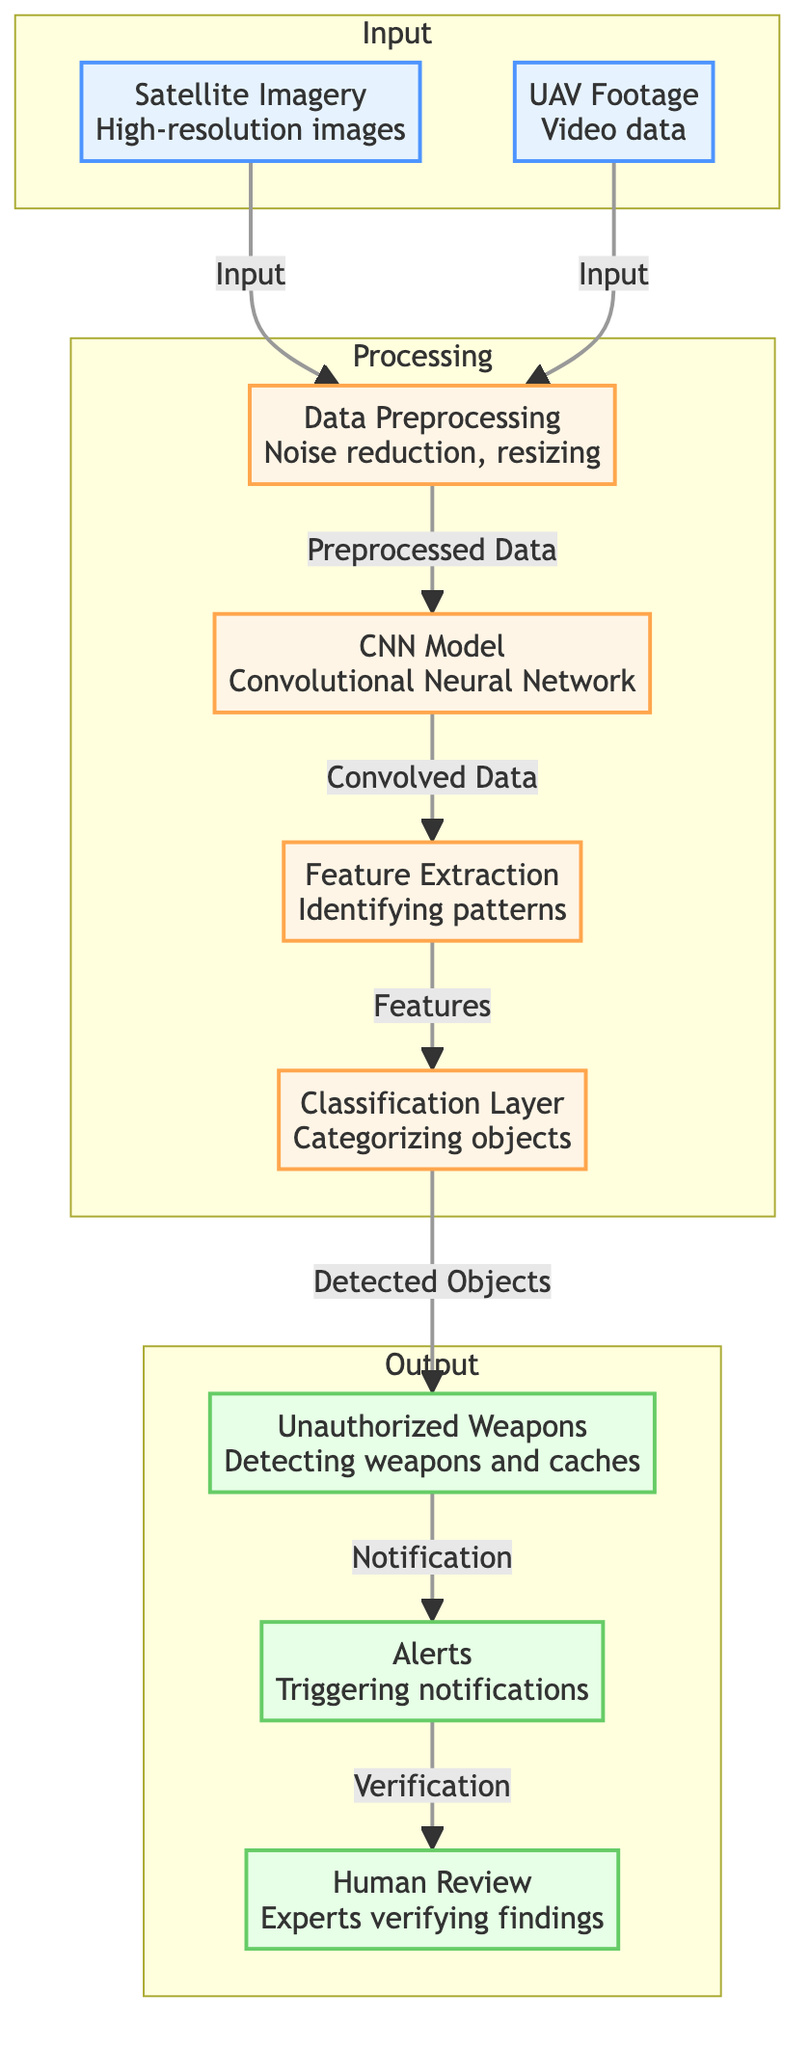What are the two types of input in the diagram? The diagram shows two inputs: one from Satellite Imagery and one from UAV Footage. Both are fed into the Data Preprocessing node as their initial step.
Answer: Satellite Imagery, UAV Footage What is the first processing step after data input? The diagram indicates that after both input types, the first processing step is Data Preprocessing. This step involves noise reduction and resizing of the images and video data.
Answer: Data Preprocessing How many processing nodes are in the diagram? Counting the individual processing steps highlighted in the diagram, we have four distinct processing nodes: Data Preprocessing, CNN Model, Feature Extraction, and Classification Layer.
Answer: Four What is the output of the classification layer node? Following the flow in the diagram, the output from the Classification Layer node means the detected objects are categorized and sent to the Unauthorized Weapons node for further analysis.
Answer: Detected Objects What follows after detecting unauthorized weapons? According to the diagram, after detecting unauthorized weapons, the subsequent action is to trigger Alerts, indicating that notifications will be sent out based on these detections.
Answer: Alerts What type of verification takes place after alerts are triggered? The diagram specifies that after the Alerts are issued, there is a Human Review step, where experts will verify the findings from the previous alert triggering process.
Answer: Human Review What type of machine learning model is used in this diagram? The diagram clearly states that a Convolutional Neural Network (CNN) model is employed in the processing sequence to enable the feature extraction and classification processes.
Answer: Convolutional Neural Network What is the role of feature extraction in this diagram? The diagram shows that Feature Extraction is responsible for identifying patterns within the processed data, which enhances the model's ability to detect unauthorized weapons.
Answer: Identifying patterns How does UAV footage relate to satellite imagery in terms of input? Within the diagram, both UAV Footage and Satellite Imagery are treated as equivalent inputs since they both lead to the same subsequent processing step, Data Preprocessing.
Answer: Equivalent inputs 